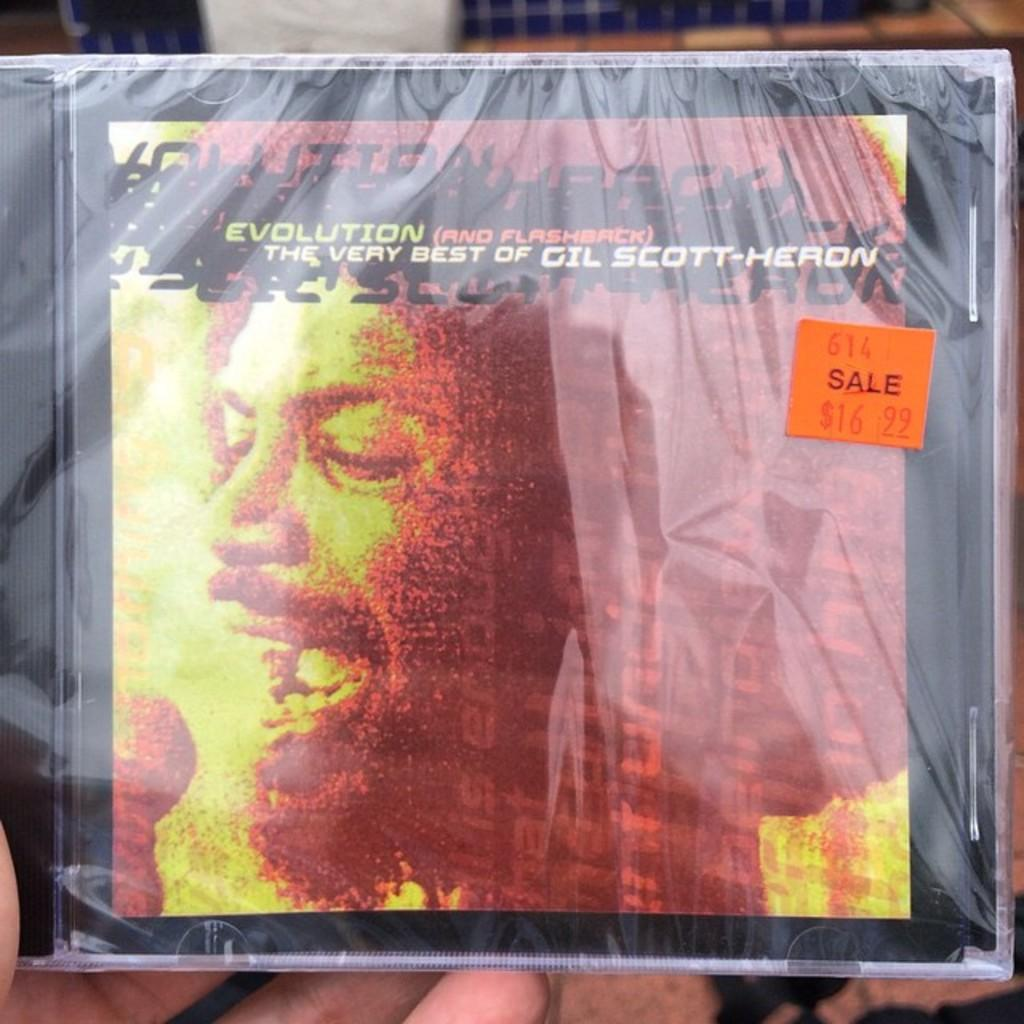What can be seen in the image? There is an object in the image. How is the object protected or covered? The object is covered with a plastic cover. Who is holding the object in the image? The object is held in a person's hand. What type of boat is being pulled by a string in the image? There is no boat or string present in the image. 